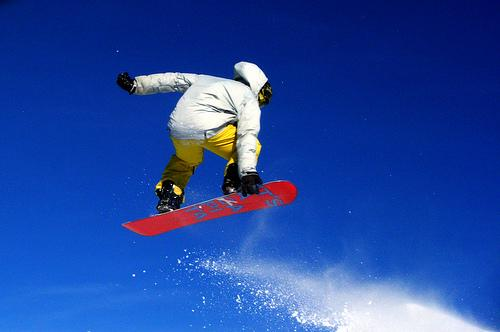Mention the main subject and their action in the picture, focusing on their clothes and surroundings. A snowboarder wearing yellow pants and a grey jacket is airborne, with flying snow dust all around. Summarize the picture in one sentence, mentioning the snowboarder's clothes and action. A snowboarder in vibrant yellow pants, grey jacket, and black gloves is in mid-air while snow dust flies about. In a precise manner, describe what the person in the image is wearing and what he's doing. Male snowboarder, wearing yellow pants, grey jacket, black gloves and goggles, is mid-jump with his red and blue snowboard. Provide a brief description of the focal point in the image. Adult snowboarder wearing yellow pants and grey jacket is airborne, with snow dust flying around. Describe the image while focusing on the snowboarder's attire and the surrounding environment. The snowboarder, clad in colorful attire including yellow pants and grey jacket, is suspended in the air as white snow dust swirls around. Provide a concise description of the image, noting the snowboarder's outfit and the scene. A snowboarder in yellow ski pants, grey jacket, and black gloves is mid-air among flying snow dust. In one sentence, tell me what's happening in the picture. A snowboarder, wearing colorful attire, is mid-air while his snowboard stirs up white snow. Mention the primary activity taking place in the image. An adult snowboarder is in mid-air, amidst flying snow dust. Highlight the main features of the image, mentioning the snowboarder's attire and the environment. Snowboarder in yellow pants, grey jacket, and black gloves is airborne, while his red and blue snowboard displaces white snow dust. Give a brief overview of the image, emphasizing the snowboarder's attire and action. Adult snowboarder in distinctive yellow pants, grey jacket, and black gloves is airborne, surrounded by snow dust. 